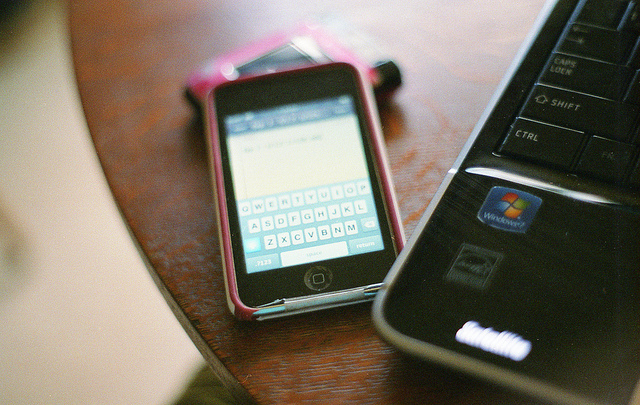Please identify all text content in this image. SHIFT CTRL M B C Z 